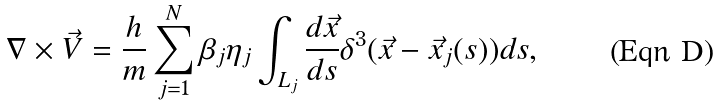<formula> <loc_0><loc_0><loc_500><loc_500>\nabla \times \vec { V } = \frac { h } { m } \sum _ { j = 1 } ^ { N } \beta _ { j } \eta _ { j } \int _ { L _ { j } } \frac { d \vec { x } } { d s } \delta ^ { 3 } ( \vec { x } - \vec { x } _ { j } ( s ) ) d s ,</formula> 